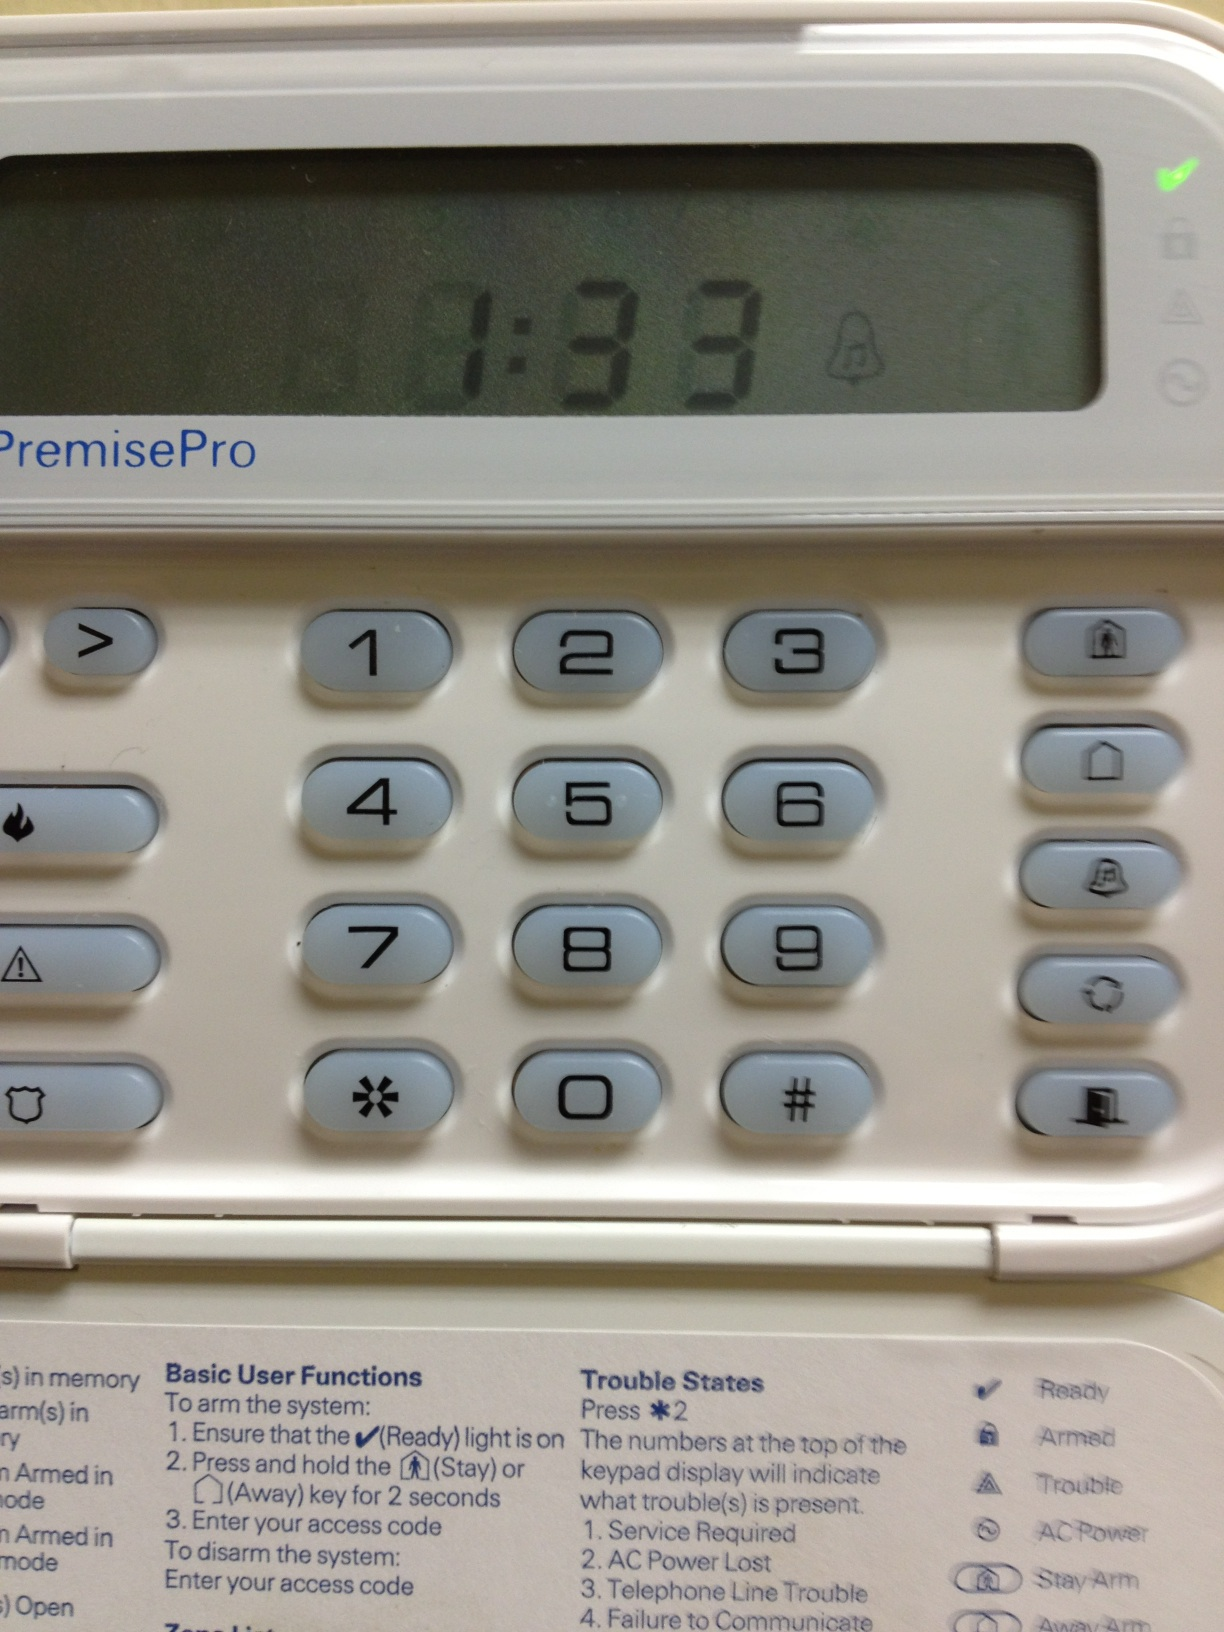Tell me more about the 'Basic User Functions' listed under the keypad. The 'Basic User Functions' describe essential operations for the security system: arming the system in stay or away mode, disarming it, and how to enter an access code which is likely unique to the user for added security. 